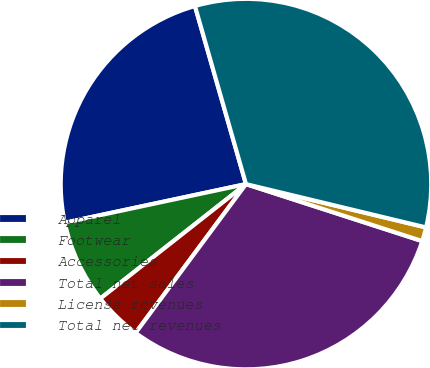Convert chart. <chart><loc_0><loc_0><loc_500><loc_500><pie_chart><fcel>Apparel<fcel>Footwear<fcel>Accessories<fcel>Total net sales<fcel>License revenues<fcel>Total net revenues<nl><fcel>23.9%<fcel>7.26%<fcel>4.24%<fcel>30.18%<fcel>1.22%<fcel>33.2%<nl></chart> 